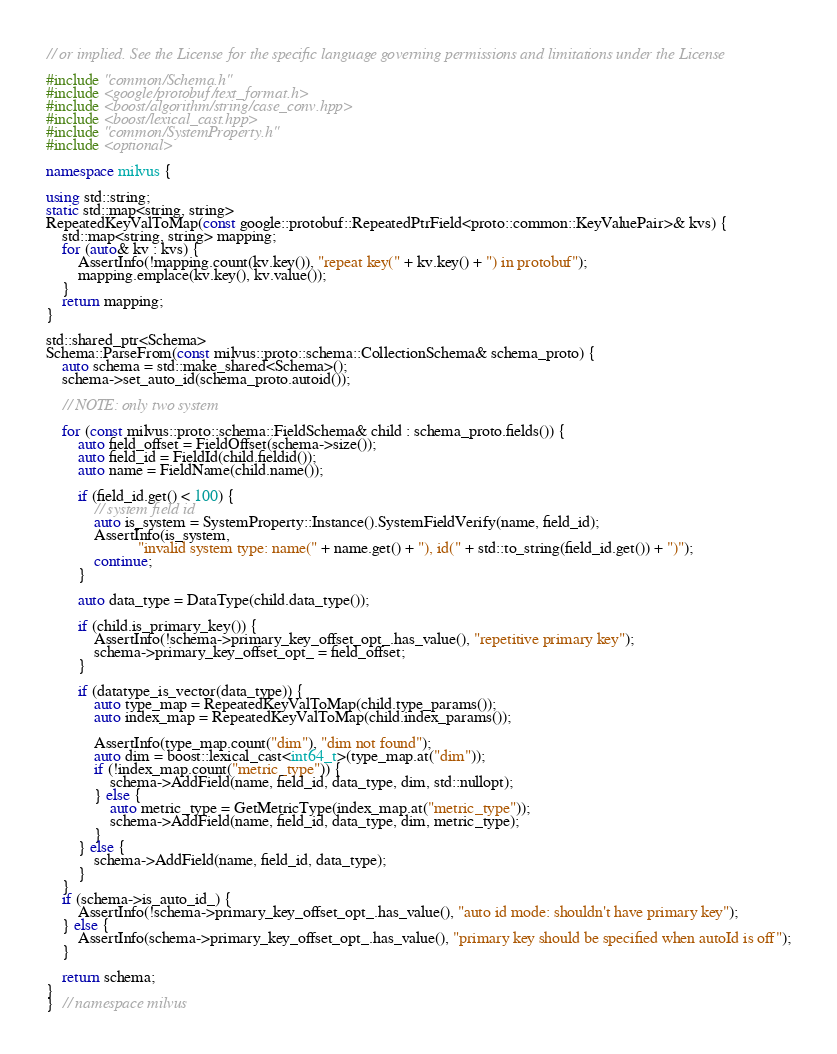<code> <loc_0><loc_0><loc_500><loc_500><_C++_>// or implied. See the License for the specific language governing permissions and limitations under the License

#include "common/Schema.h"
#include <google/protobuf/text_format.h>
#include <boost/algorithm/string/case_conv.hpp>
#include <boost/lexical_cast.hpp>
#include "common/SystemProperty.h"
#include <optional>

namespace milvus {

using std::string;
static std::map<string, string>
RepeatedKeyValToMap(const google::protobuf::RepeatedPtrField<proto::common::KeyValuePair>& kvs) {
    std::map<string, string> mapping;
    for (auto& kv : kvs) {
        AssertInfo(!mapping.count(kv.key()), "repeat key(" + kv.key() + ") in protobuf");
        mapping.emplace(kv.key(), kv.value());
    }
    return mapping;
}

std::shared_ptr<Schema>
Schema::ParseFrom(const milvus::proto::schema::CollectionSchema& schema_proto) {
    auto schema = std::make_shared<Schema>();
    schema->set_auto_id(schema_proto.autoid());

    // NOTE: only two system

    for (const milvus::proto::schema::FieldSchema& child : schema_proto.fields()) {
        auto field_offset = FieldOffset(schema->size());
        auto field_id = FieldId(child.fieldid());
        auto name = FieldName(child.name());

        if (field_id.get() < 100) {
            // system field id
            auto is_system = SystemProperty::Instance().SystemFieldVerify(name, field_id);
            AssertInfo(is_system,
                       "invalid system type: name(" + name.get() + "), id(" + std::to_string(field_id.get()) + ")");
            continue;
        }

        auto data_type = DataType(child.data_type());

        if (child.is_primary_key()) {
            AssertInfo(!schema->primary_key_offset_opt_.has_value(), "repetitive primary key");
            schema->primary_key_offset_opt_ = field_offset;
        }

        if (datatype_is_vector(data_type)) {
            auto type_map = RepeatedKeyValToMap(child.type_params());
            auto index_map = RepeatedKeyValToMap(child.index_params());

            AssertInfo(type_map.count("dim"), "dim not found");
            auto dim = boost::lexical_cast<int64_t>(type_map.at("dim"));
            if (!index_map.count("metric_type")) {
                schema->AddField(name, field_id, data_type, dim, std::nullopt);
            } else {
                auto metric_type = GetMetricType(index_map.at("metric_type"));
                schema->AddField(name, field_id, data_type, dim, metric_type);
            }
        } else {
            schema->AddField(name, field_id, data_type);
        }
    }
    if (schema->is_auto_id_) {
        AssertInfo(!schema->primary_key_offset_opt_.has_value(), "auto id mode: shouldn't have primary key");
    } else {
        AssertInfo(schema->primary_key_offset_opt_.has_value(), "primary key should be specified when autoId is off");
    }

    return schema;
}
}  // namespace milvus
</code> 